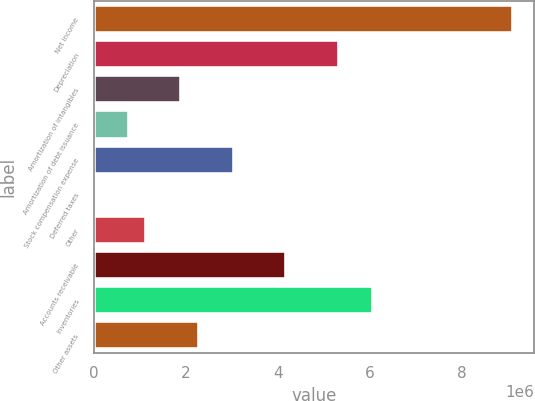Convert chart to OTSL. <chart><loc_0><loc_0><loc_500><loc_500><bar_chart><fcel>Net income<fcel>Depreciation<fcel>Amortization of intangibles<fcel>Amortization of debt issuance<fcel>Stock compensation expense<fcel>Deferred taxes<fcel>Other<fcel>Accounts receivable<fcel>Inventories<fcel>Other assets<nl><fcel>9.10509e+06<fcel>5.31498e+06<fcel>1.90389e+06<fcel>766857<fcel>3.04092e+06<fcel>8836<fcel>1.14587e+06<fcel>4.17795e+06<fcel>6.07301e+06<fcel>2.2829e+06<nl></chart> 